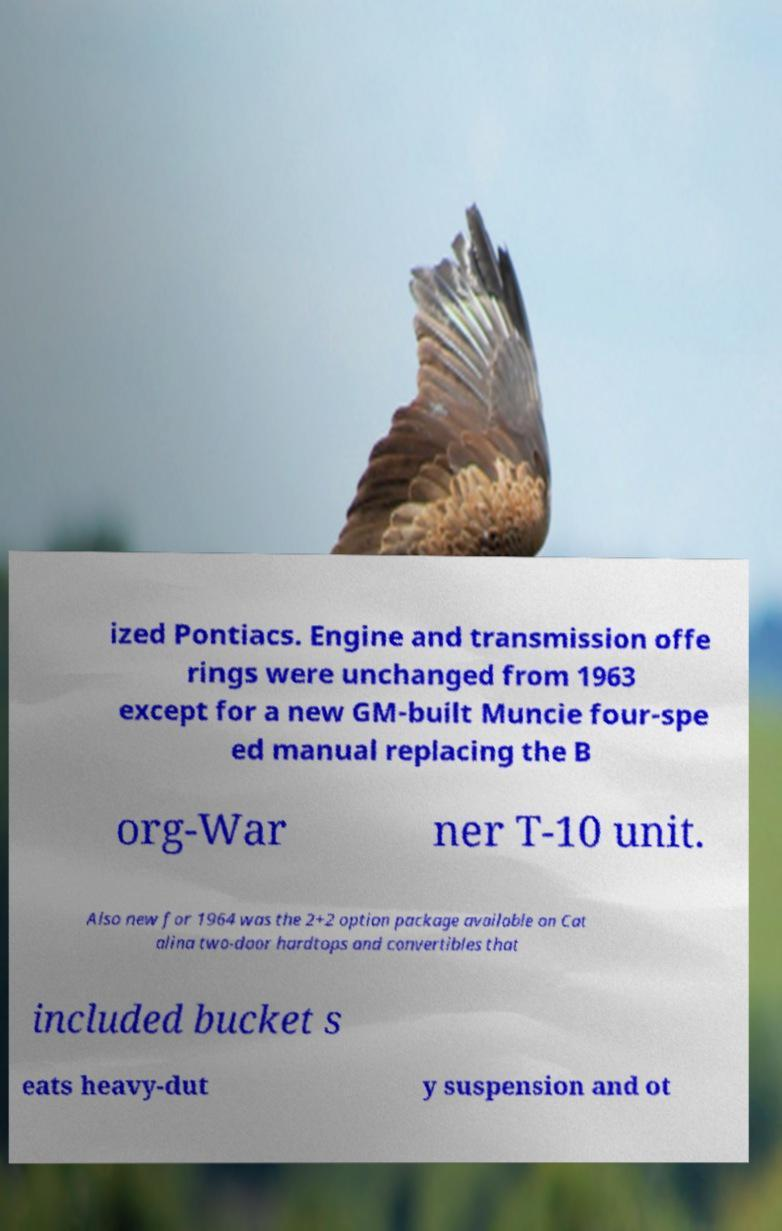There's text embedded in this image that I need extracted. Can you transcribe it verbatim? ized Pontiacs. Engine and transmission offe rings were unchanged from 1963 except for a new GM-built Muncie four-spe ed manual replacing the B org-War ner T-10 unit. Also new for 1964 was the 2+2 option package available on Cat alina two-door hardtops and convertibles that included bucket s eats heavy-dut y suspension and ot 